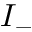<formula> <loc_0><loc_0><loc_500><loc_500>I _ { - }</formula> 